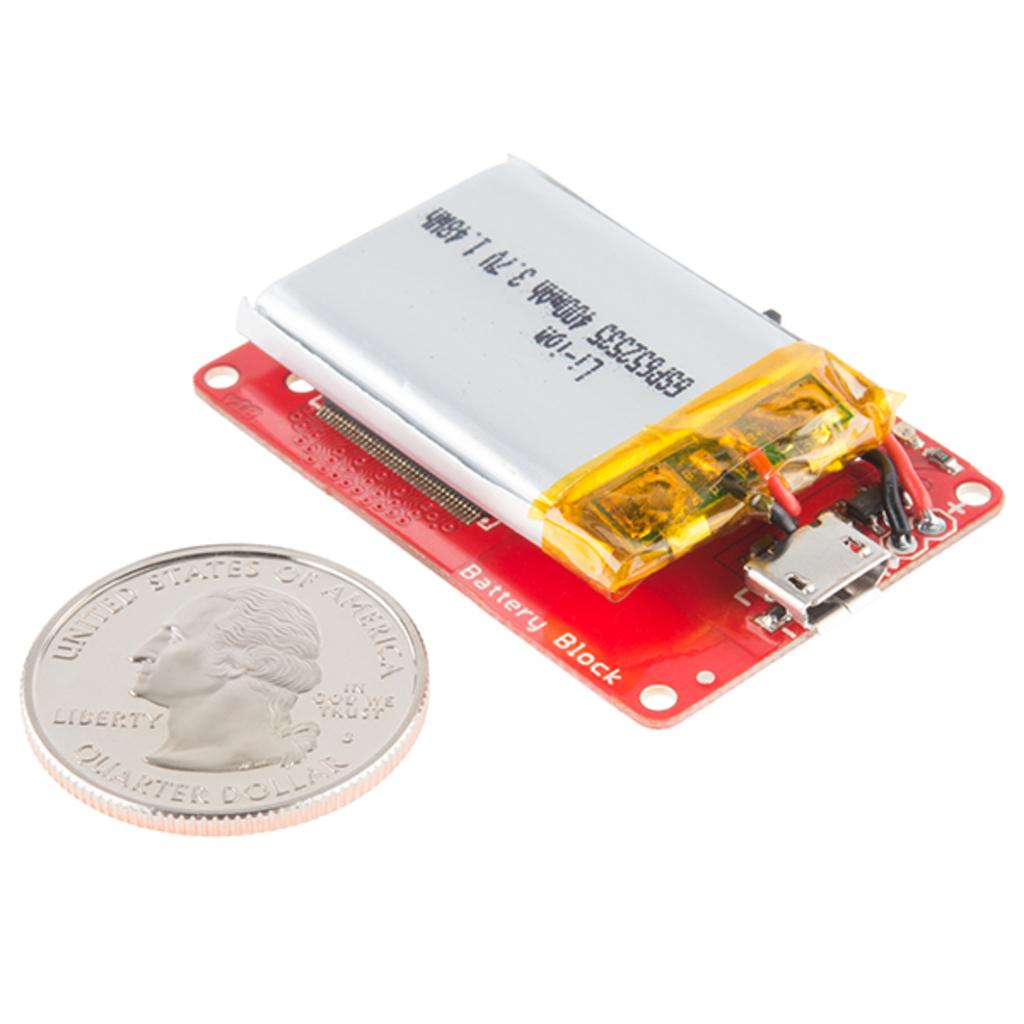<image>
Create a compact narrative representing the image presented. A US quarter sits next to a battery to illustrate its size. 